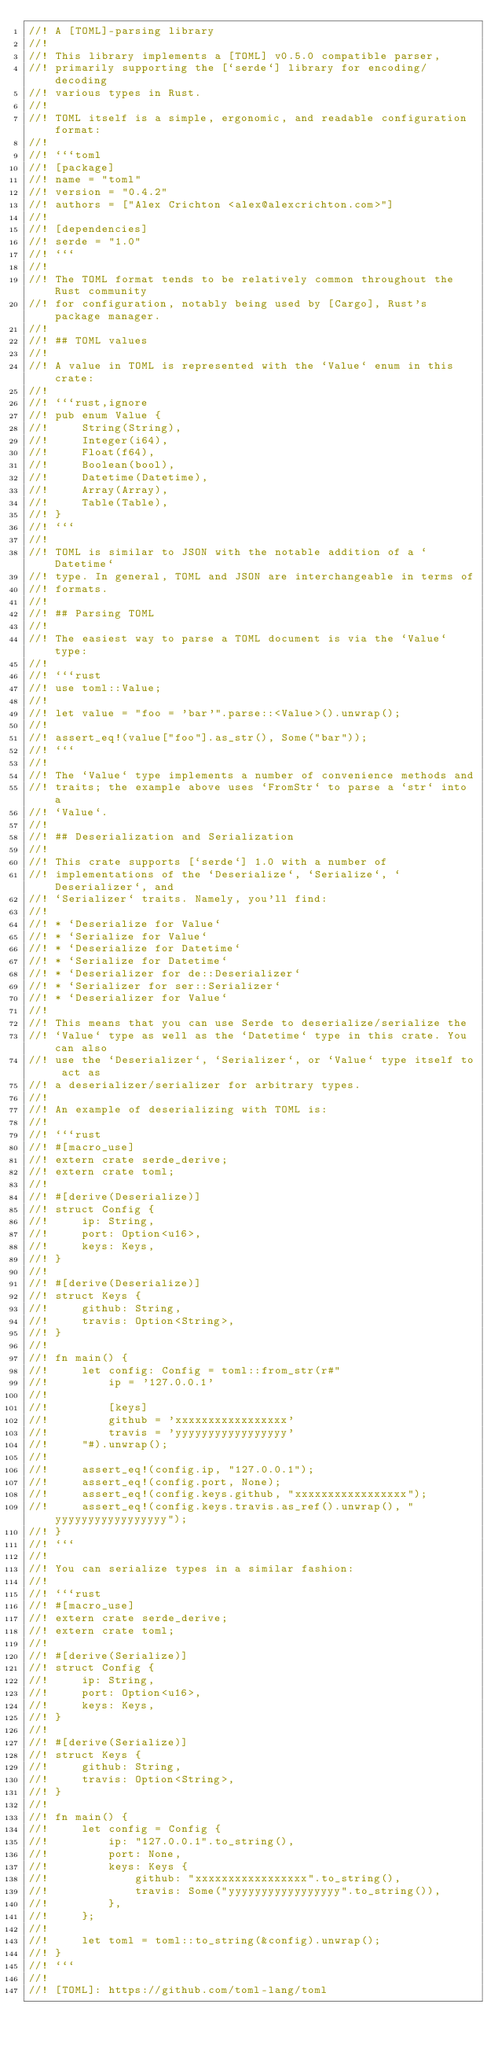<code> <loc_0><loc_0><loc_500><loc_500><_Rust_>//! A [TOML]-parsing library
//!
//! This library implements a [TOML] v0.5.0 compatible parser,
//! primarily supporting the [`serde`] library for encoding/decoding
//! various types in Rust.
//!
//! TOML itself is a simple, ergonomic, and readable configuration format:
//!
//! ```toml
//! [package]
//! name = "toml"
//! version = "0.4.2"
//! authors = ["Alex Crichton <alex@alexcrichton.com>"]
//!
//! [dependencies]
//! serde = "1.0"
//! ```
//!
//! The TOML format tends to be relatively common throughout the Rust community
//! for configuration, notably being used by [Cargo], Rust's package manager.
//!
//! ## TOML values
//!
//! A value in TOML is represented with the `Value` enum in this crate:
//!
//! ```rust,ignore
//! pub enum Value {
//!     String(String),
//!     Integer(i64),
//!     Float(f64),
//!     Boolean(bool),
//!     Datetime(Datetime),
//!     Array(Array),
//!     Table(Table),
//! }
//! ```
//!
//! TOML is similar to JSON with the notable addition of a `Datetime`
//! type. In general, TOML and JSON are interchangeable in terms of
//! formats.
//!
//! ## Parsing TOML
//!
//! The easiest way to parse a TOML document is via the `Value` type:
//!
//! ```rust
//! use toml::Value;
//!
//! let value = "foo = 'bar'".parse::<Value>().unwrap();
//!
//! assert_eq!(value["foo"].as_str(), Some("bar"));
//! ```
//!
//! The `Value` type implements a number of convenience methods and
//! traits; the example above uses `FromStr` to parse a `str` into a
//! `Value`.
//!
//! ## Deserialization and Serialization
//!
//! This crate supports [`serde`] 1.0 with a number of
//! implementations of the `Deserialize`, `Serialize`, `Deserializer`, and
//! `Serializer` traits. Namely, you'll find:
//!
//! * `Deserialize for Value`
//! * `Serialize for Value`
//! * `Deserialize for Datetime`
//! * `Serialize for Datetime`
//! * `Deserializer for de::Deserializer`
//! * `Serializer for ser::Serializer`
//! * `Deserializer for Value`
//!
//! This means that you can use Serde to deserialize/serialize the
//! `Value` type as well as the `Datetime` type in this crate. You can also
//! use the `Deserializer`, `Serializer`, or `Value` type itself to act as
//! a deserializer/serializer for arbitrary types.
//!
//! An example of deserializing with TOML is:
//!
//! ```rust
//! #[macro_use]
//! extern crate serde_derive;
//! extern crate toml;
//!
//! #[derive(Deserialize)]
//! struct Config {
//!     ip: String,
//!     port: Option<u16>,
//!     keys: Keys,
//! }
//!
//! #[derive(Deserialize)]
//! struct Keys {
//!     github: String,
//!     travis: Option<String>,
//! }
//!
//! fn main() {
//!     let config: Config = toml::from_str(r#"
//!         ip = '127.0.0.1'
//!
//!         [keys]
//!         github = 'xxxxxxxxxxxxxxxxx'
//!         travis = 'yyyyyyyyyyyyyyyyy'
//!     "#).unwrap();
//!
//!     assert_eq!(config.ip, "127.0.0.1");
//!     assert_eq!(config.port, None);
//!     assert_eq!(config.keys.github, "xxxxxxxxxxxxxxxxx");
//!     assert_eq!(config.keys.travis.as_ref().unwrap(), "yyyyyyyyyyyyyyyyy");
//! }
//! ```
//!
//! You can serialize types in a similar fashion:
//!
//! ```rust
//! #[macro_use]
//! extern crate serde_derive;
//! extern crate toml;
//!
//! #[derive(Serialize)]
//! struct Config {
//!     ip: String,
//!     port: Option<u16>,
//!     keys: Keys,
//! }
//!
//! #[derive(Serialize)]
//! struct Keys {
//!     github: String,
//!     travis: Option<String>,
//! }
//!
//! fn main() {
//!     let config = Config {
//!         ip: "127.0.0.1".to_string(),
//!         port: None,
//!         keys: Keys {
//!             github: "xxxxxxxxxxxxxxxxx".to_string(),
//!             travis: Some("yyyyyyyyyyyyyyyyy".to_string()),
//!         },
//!     };
//!
//!     let toml = toml::to_string(&config).unwrap();
//! }
//! ```
//!
//! [TOML]: https://github.com/toml-lang/toml</code> 